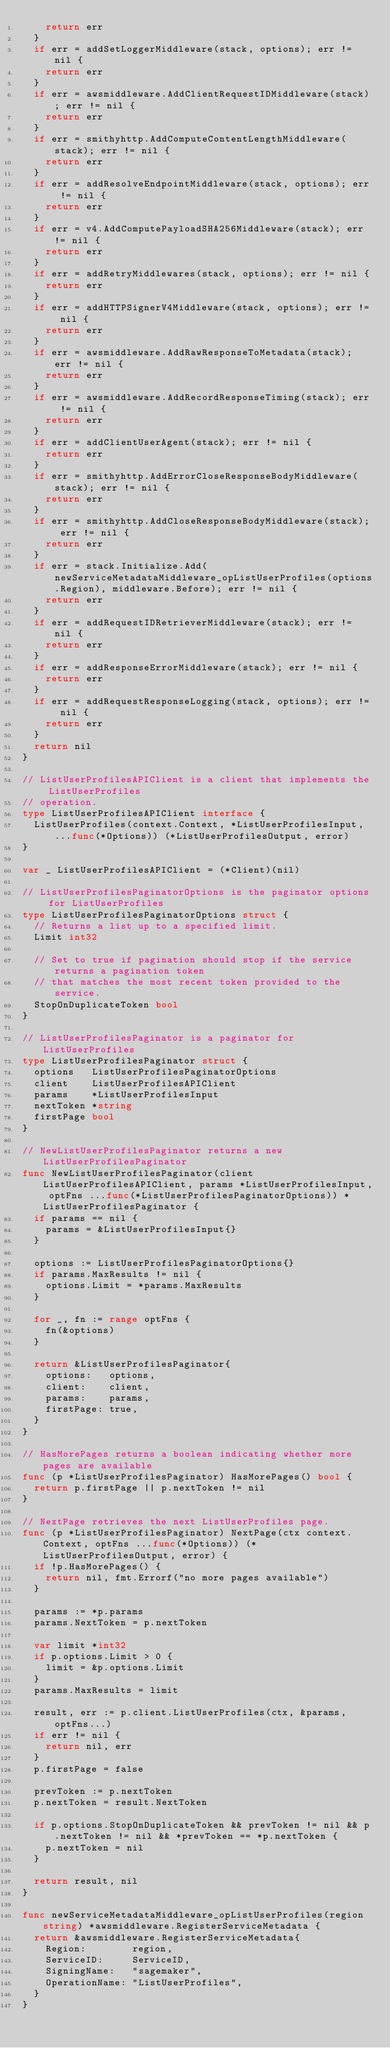<code> <loc_0><loc_0><loc_500><loc_500><_Go_>		return err
	}
	if err = addSetLoggerMiddleware(stack, options); err != nil {
		return err
	}
	if err = awsmiddleware.AddClientRequestIDMiddleware(stack); err != nil {
		return err
	}
	if err = smithyhttp.AddComputeContentLengthMiddleware(stack); err != nil {
		return err
	}
	if err = addResolveEndpointMiddleware(stack, options); err != nil {
		return err
	}
	if err = v4.AddComputePayloadSHA256Middleware(stack); err != nil {
		return err
	}
	if err = addRetryMiddlewares(stack, options); err != nil {
		return err
	}
	if err = addHTTPSignerV4Middleware(stack, options); err != nil {
		return err
	}
	if err = awsmiddleware.AddRawResponseToMetadata(stack); err != nil {
		return err
	}
	if err = awsmiddleware.AddRecordResponseTiming(stack); err != nil {
		return err
	}
	if err = addClientUserAgent(stack); err != nil {
		return err
	}
	if err = smithyhttp.AddErrorCloseResponseBodyMiddleware(stack); err != nil {
		return err
	}
	if err = smithyhttp.AddCloseResponseBodyMiddleware(stack); err != nil {
		return err
	}
	if err = stack.Initialize.Add(newServiceMetadataMiddleware_opListUserProfiles(options.Region), middleware.Before); err != nil {
		return err
	}
	if err = addRequestIDRetrieverMiddleware(stack); err != nil {
		return err
	}
	if err = addResponseErrorMiddleware(stack); err != nil {
		return err
	}
	if err = addRequestResponseLogging(stack, options); err != nil {
		return err
	}
	return nil
}

// ListUserProfilesAPIClient is a client that implements the ListUserProfiles
// operation.
type ListUserProfilesAPIClient interface {
	ListUserProfiles(context.Context, *ListUserProfilesInput, ...func(*Options)) (*ListUserProfilesOutput, error)
}

var _ ListUserProfilesAPIClient = (*Client)(nil)

// ListUserProfilesPaginatorOptions is the paginator options for ListUserProfiles
type ListUserProfilesPaginatorOptions struct {
	// Returns a list up to a specified limit.
	Limit int32

	// Set to true if pagination should stop if the service returns a pagination token
	// that matches the most recent token provided to the service.
	StopOnDuplicateToken bool
}

// ListUserProfilesPaginator is a paginator for ListUserProfiles
type ListUserProfilesPaginator struct {
	options   ListUserProfilesPaginatorOptions
	client    ListUserProfilesAPIClient
	params    *ListUserProfilesInput
	nextToken *string
	firstPage bool
}

// NewListUserProfilesPaginator returns a new ListUserProfilesPaginator
func NewListUserProfilesPaginator(client ListUserProfilesAPIClient, params *ListUserProfilesInput, optFns ...func(*ListUserProfilesPaginatorOptions)) *ListUserProfilesPaginator {
	if params == nil {
		params = &ListUserProfilesInput{}
	}

	options := ListUserProfilesPaginatorOptions{}
	if params.MaxResults != nil {
		options.Limit = *params.MaxResults
	}

	for _, fn := range optFns {
		fn(&options)
	}

	return &ListUserProfilesPaginator{
		options:   options,
		client:    client,
		params:    params,
		firstPage: true,
	}
}

// HasMorePages returns a boolean indicating whether more pages are available
func (p *ListUserProfilesPaginator) HasMorePages() bool {
	return p.firstPage || p.nextToken != nil
}

// NextPage retrieves the next ListUserProfiles page.
func (p *ListUserProfilesPaginator) NextPage(ctx context.Context, optFns ...func(*Options)) (*ListUserProfilesOutput, error) {
	if !p.HasMorePages() {
		return nil, fmt.Errorf("no more pages available")
	}

	params := *p.params
	params.NextToken = p.nextToken

	var limit *int32
	if p.options.Limit > 0 {
		limit = &p.options.Limit
	}
	params.MaxResults = limit

	result, err := p.client.ListUserProfiles(ctx, &params, optFns...)
	if err != nil {
		return nil, err
	}
	p.firstPage = false

	prevToken := p.nextToken
	p.nextToken = result.NextToken

	if p.options.StopOnDuplicateToken && prevToken != nil && p.nextToken != nil && *prevToken == *p.nextToken {
		p.nextToken = nil
	}

	return result, nil
}

func newServiceMetadataMiddleware_opListUserProfiles(region string) *awsmiddleware.RegisterServiceMetadata {
	return &awsmiddleware.RegisterServiceMetadata{
		Region:        region,
		ServiceID:     ServiceID,
		SigningName:   "sagemaker",
		OperationName: "ListUserProfiles",
	}
}
</code> 